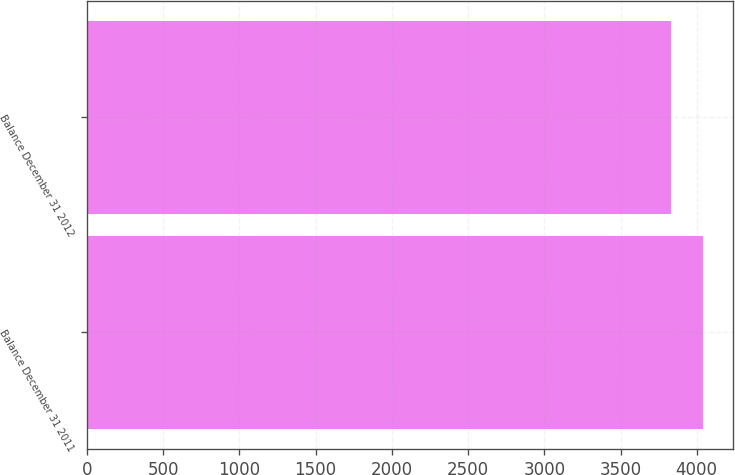Convert chart to OTSL. <chart><loc_0><loc_0><loc_500><loc_500><bar_chart><fcel>Balance December 31 2011<fcel>Balance December 31 2012<nl><fcel>4038.8<fcel>3833.2<nl></chart> 